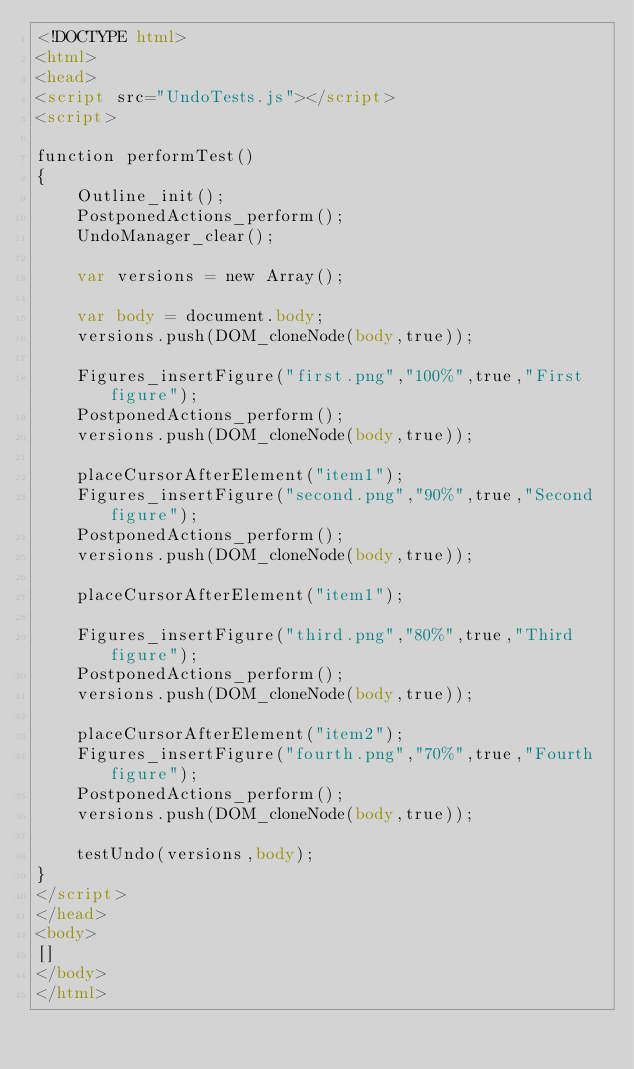<code> <loc_0><loc_0><loc_500><loc_500><_HTML_><!DOCTYPE html>
<html>
<head>
<script src="UndoTests.js"></script>
<script>

function performTest()
{
    Outline_init();
    PostponedActions_perform();
    UndoManager_clear();

    var versions = new Array();

    var body = document.body;
    versions.push(DOM_cloneNode(body,true));

    Figures_insertFigure("first.png","100%",true,"First figure");
    PostponedActions_perform();
    versions.push(DOM_cloneNode(body,true));

    placeCursorAfterElement("item1");
    Figures_insertFigure("second.png","90%",true,"Second figure");
    PostponedActions_perform();
    versions.push(DOM_cloneNode(body,true));

    placeCursorAfterElement("item1");

    Figures_insertFigure("third.png","80%",true,"Third figure");
    PostponedActions_perform();
    versions.push(DOM_cloneNode(body,true));

    placeCursorAfterElement("item2");
    Figures_insertFigure("fourth.png","70%",true,"Fourth figure");
    PostponedActions_perform();
    versions.push(DOM_cloneNode(body,true));

    testUndo(versions,body);
}
</script>
</head>
<body>
[]
</body>
</html>
</code> 